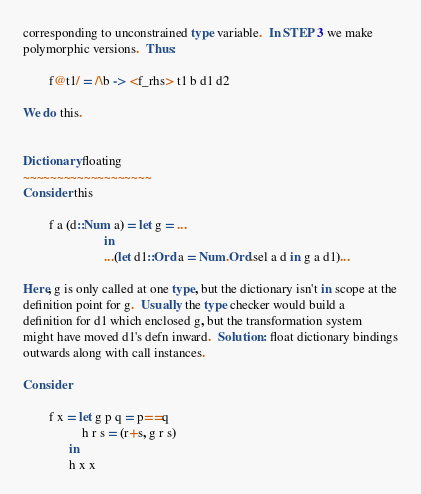<code> <loc_0><loc_0><loc_500><loc_500><_Haskell_>corresponding to unconstrained type variable.  In STEP 3 we make
polymorphic versions.  Thus:

        f@t1/ = /\b -> <f_rhs> t1 b d1 d2

We do this.


Dictionary floating
~~~~~~~~~~~~~~~~~~~
Consider this

        f a (d::Num a) = let g = ...
                         in
                         ...(let d1::Ord a = Num.Ord.sel a d in g a d1)...

Here, g is only called at one type, but the dictionary isn't in scope at the
definition point for g.  Usually the type checker would build a
definition for d1 which enclosed g, but the transformation system
might have moved d1's defn inward.  Solution: float dictionary bindings
outwards along with call instances.

Consider

        f x = let g p q = p==q
                  h r s = (r+s, g r s)
              in
              h x x

</code> 